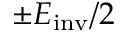<formula> <loc_0><loc_0><loc_500><loc_500>\pm E _ { i n v } / 2</formula> 